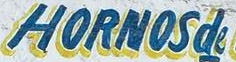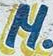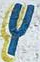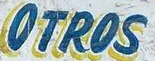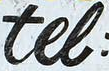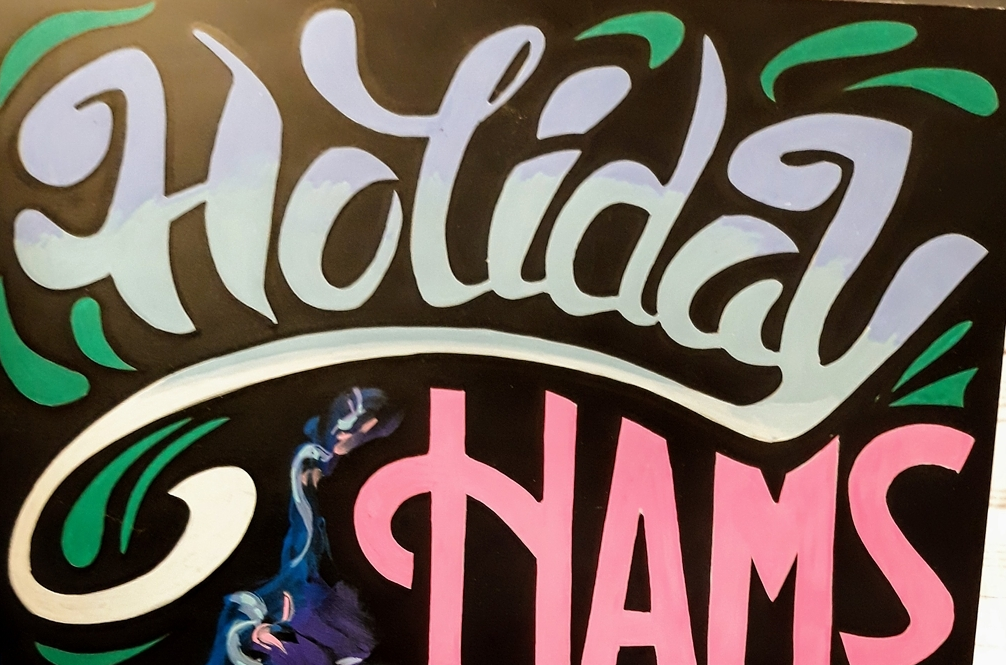What words can you see in these images in sequence, separated by a semicolon? HORNOSde; M; Y; OTROS; tel; Holiday 